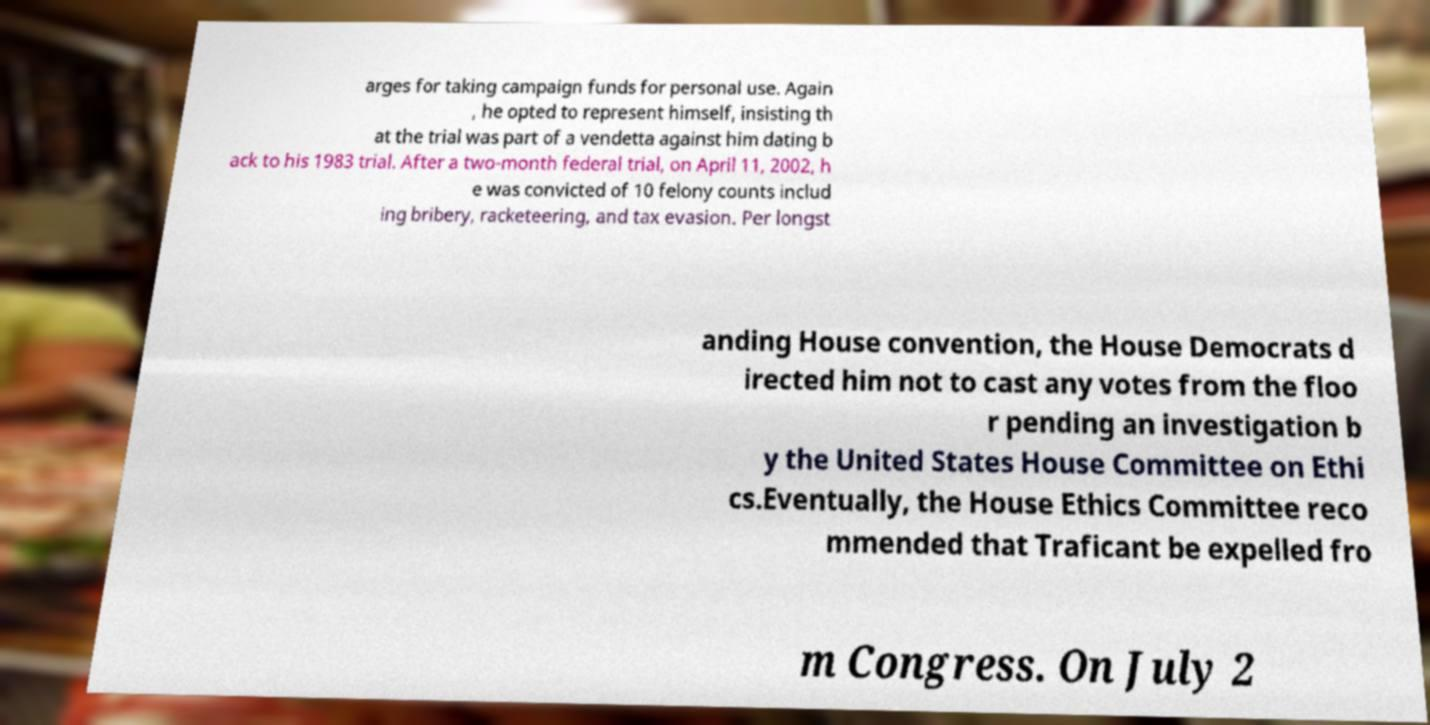Can you read and provide the text displayed in the image?This photo seems to have some interesting text. Can you extract and type it out for me? arges for taking campaign funds for personal use. Again , he opted to represent himself, insisting th at the trial was part of a vendetta against him dating b ack to his 1983 trial. After a two-month federal trial, on April 11, 2002, h e was convicted of 10 felony counts includ ing bribery, racketeering, and tax evasion. Per longst anding House convention, the House Democrats d irected him not to cast any votes from the floo r pending an investigation b y the United States House Committee on Ethi cs.Eventually, the House Ethics Committee reco mmended that Traficant be expelled fro m Congress. On July 2 